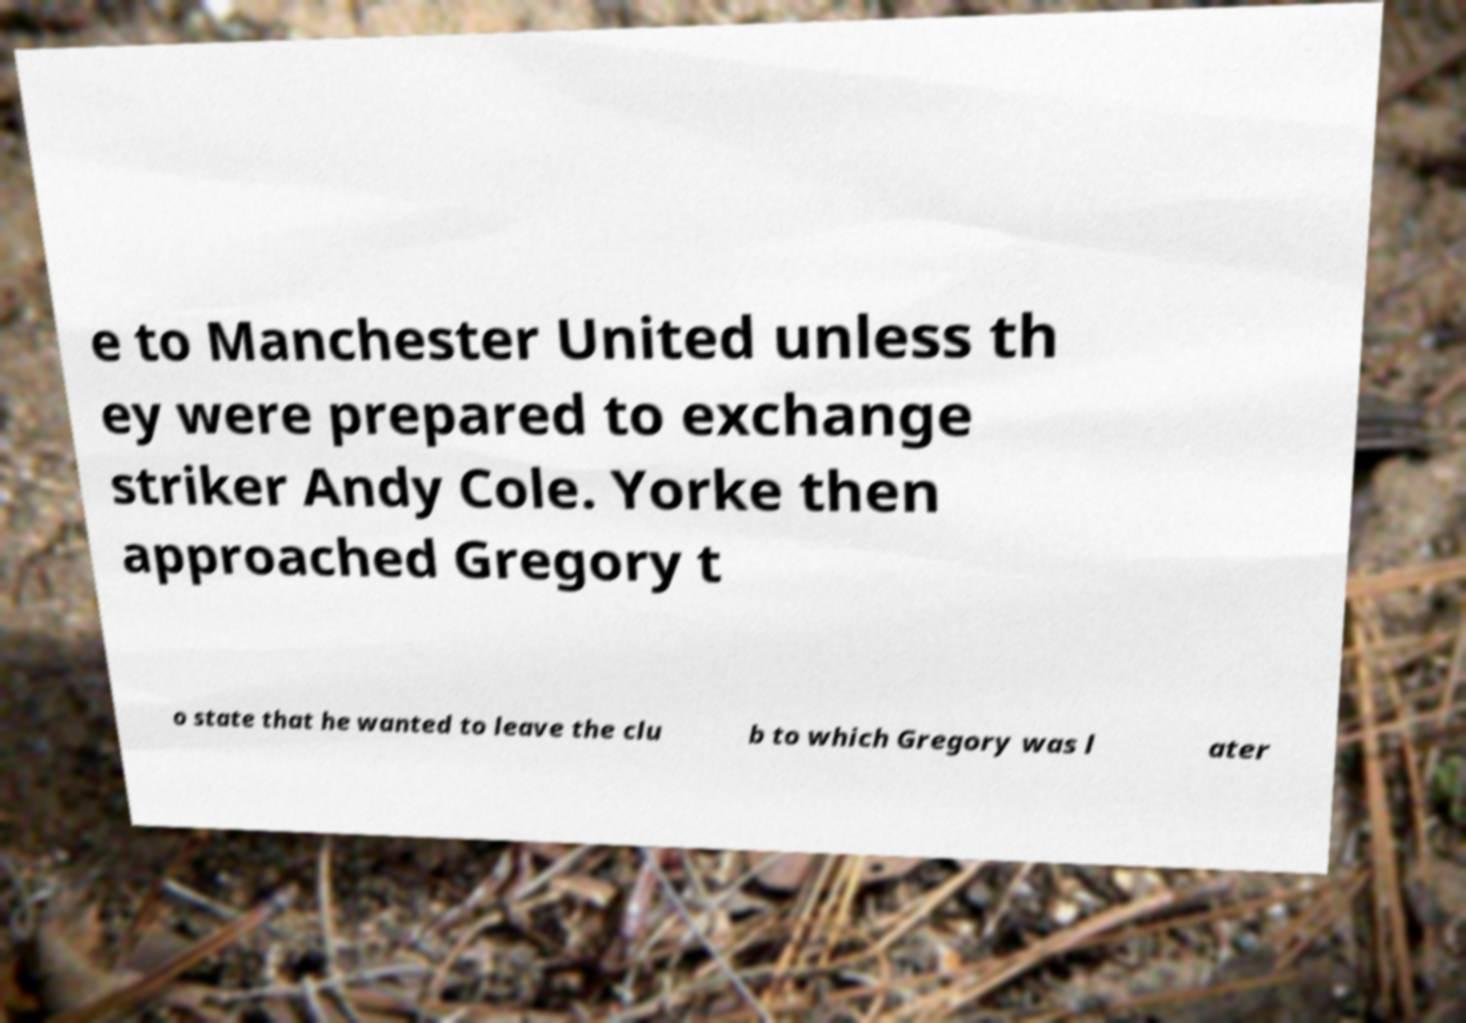Could you assist in decoding the text presented in this image and type it out clearly? e to Manchester United unless th ey were prepared to exchange striker Andy Cole. Yorke then approached Gregory t o state that he wanted to leave the clu b to which Gregory was l ater 